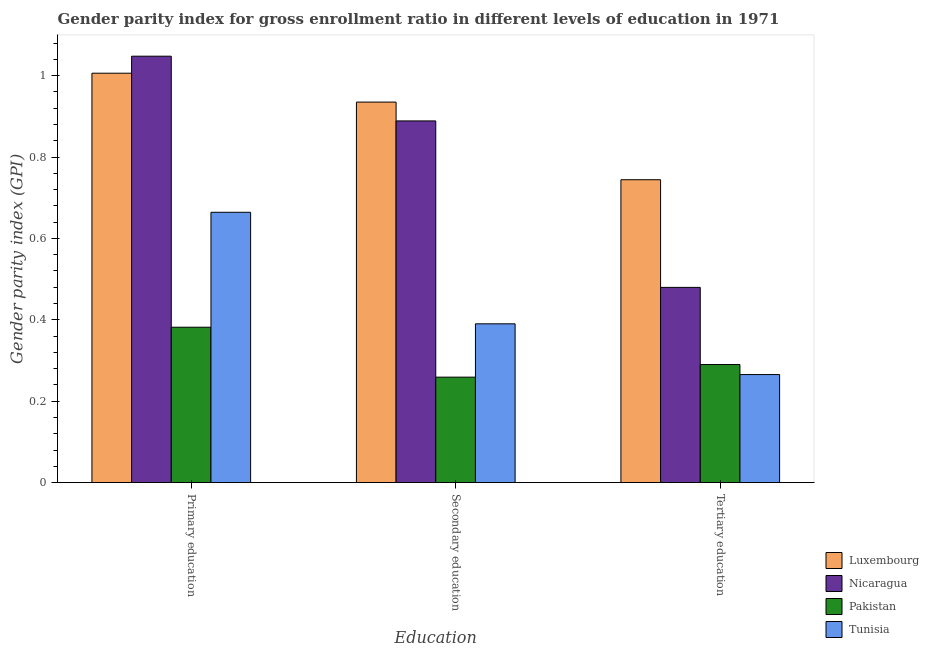How many groups of bars are there?
Provide a short and direct response. 3. How many bars are there on the 3rd tick from the right?
Ensure brevity in your answer.  4. What is the gender parity index in primary education in Nicaragua?
Provide a succinct answer. 1.05. Across all countries, what is the maximum gender parity index in tertiary education?
Your response must be concise. 0.74. Across all countries, what is the minimum gender parity index in tertiary education?
Your response must be concise. 0.27. In which country was the gender parity index in primary education maximum?
Offer a terse response. Nicaragua. In which country was the gender parity index in primary education minimum?
Offer a very short reply. Pakistan. What is the total gender parity index in secondary education in the graph?
Your answer should be very brief. 2.47. What is the difference between the gender parity index in tertiary education in Luxembourg and that in Pakistan?
Make the answer very short. 0.45. What is the difference between the gender parity index in primary education in Nicaragua and the gender parity index in secondary education in Luxembourg?
Keep it short and to the point. 0.11. What is the average gender parity index in tertiary education per country?
Make the answer very short. 0.44. What is the difference between the gender parity index in tertiary education and gender parity index in secondary education in Luxembourg?
Your answer should be very brief. -0.19. In how many countries, is the gender parity index in tertiary education greater than 0.4 ?
Provide a short and direct response. 2. What is the ratio of the gender parity index in secondary education in Pakistan to that in Luxembourg?
Keep it short and to the point. 0.28. Is the gender parity index in primary education in Luxembourg less than that in Nicaragua?
Offer a terse response. Yes. Is the difference between the gender parity index in secondary education in Nicaragua and Luxembourg greater than the difference between the gender parity index in primary education in Nicaragua and Luxembourg?
Ensure brevity in your answer.  No. What is the difference between the highest and the second highest gender parity index in tertiary education?
Give a very brief answer. 0.26. What is the difference between the highest and the lowest gender parity index in tertiary education?
Offer a very short reply. 0.48. In how many countries, is the gender parity index in tertiary education greater than the average gender parity index in tertiary education taken over all countries?
Your answer should be compact. 2. Is the sum of the gender parity index in primary education in Tunisia and Luxembourg greater than the maximum gender parity index in tertiary education across all countries?
Offer a terse response. Yes. What does the 2nd bar from the left in Primary education represents?
Offer a very short reply. Nicaragua. What does the 1st bar from the right in Secondary education represents?
Give a very brief answer. Tunisia. Is it the case that in every country, the sum of the gender parity index in primary education and gender parity index in secondary education is greater than the gender parity index in tertiary education?
Your answer should be very brief. Yes. Does the graph contain any zero values?
Give a very brief answer. No. Where does the legend appear in the graph?
Give a very brief answer. Bottom right. How many legend labels are there?
Offer a terse response. 4. What is the title of the graph?
Your response must be concise. Gender parity index for gross enrollment ratio in different levels of education in 1971. What is the label or title of the X-axis?
Keep it short and to the point. Education. What is the label or title of the Y-axis?
Provide a short and direct response. Gender parity index (GPI). What is the Gender parity index (GPI) of Luxembourg in Primary education?
Give a very brief answer. 1.01. What is the Gender parity index (GPI) of Nicaragua in Primary education?
Your answer should be very brief. 1.05. What is the Gender parity index (GPI) of Pakistan in Primary education?
Give a very brief answer. 0.38. What is the Gender parity index (GPI) of Tunisia in Primary education?
Ensure brevity in your answer.  0.66. What is the Gender parity index (GPI) in Luxembourg in Secondary education?
Offer a terse response. 0.93. What is the Gender parity index (GPI) of Nicaragua in Secondary education?
Ensure brevity in your answer.  0.89. What is the Gender parity index (GPI) of Pakistan in Secondary education?
Provide a succinct answer. 0.26. What is the Gender parity index (GPI) in Tunisia in Secondary education?
Provide a short and direct response. 0.39. What is the Gender parity index (GPI) in Luxembourg in Tertiary education?
Keep it short and to the point. 0.74. What is the Gender parity index (GPI) in Nicaragua in Tertiary education?
Keep it short and to the point. 0.48. What is the Gender parity index (GPI) in Pakistan in Tertiary education?
Provide a succinct answer. 0.29. What is the Gender parity index (GPI) of Tunisia in Tertiary education?
Provide a succinct answer. 0.27. Across all Education, what is the maximum Gender parity index (GPI) of Luxembourg?
Offer a terse response. 1.01. Across all Education, what is the maximum Gender parity index (GPI) of Nicaragua?
Your response must be concise. 1.05. Across all Education, what is the maximum Gender parity index (GPI) of Pakistan?
Make the answer very short. 0.38. Across all Education, what is the maximum Gender parity index (GPI) of Tunisia?
Your answer should be compact. 0.66. Across all Education, what is the minimum Gender parity index (GPI) of Luxembourg?
Keep it short and to the point. 0.74. Across all Education, what is the minimum Gender parity index (GPI) in Nicaragua?
Ensure brevity in your answer.  0.48. Across all Education, what is the minimum Gender parity index (GPI) of Pakistan?
Provide a succinct answer. 0.26. Across all Education, what is the minimum Gender parity index (GPI) in Tunisia?
Make the answer very short. 0.27. What is the total Gender parity index (GPI) of Luxembourg in the graph?
Keep it short and to the point. 2.69. What is the total Gender parity index (GPI) in Nicaragua in the graph?
Offer a very short reply. 2.42. What is the total Gender parity index (GPI) of Pakistan in the graph?
Keep it short and to the point. 0.93. What is the total Gender parity index (GPI) in Tunisia in the graph?
Offer a very short reply. 1.32. What is the difference between the Gender parity index (GPI) of Luxembourg in Primary education and that in Secondary education?
Your response must be concise. 0.07. What is the difference between the Gender parity index (GPI) of Nicaragua in Primary education and that in Secondary education?
Keep it short and to the point. 0.16. What is the difference between the Gender parity index (GPI) in Pakistan in Primary education and that in Secondary education?
Offer a very short reply. 0.12. What is the difference between the Gender parity index (GPI) in Tunisia in Primary education and that in Secondary education?
Ensure brevity in your answer.  0.27. What is the difference between the Gender parity index (GPI) of Luxembourg in Primary education and that in Tertiary education?
Your answer should be very brief. 0.26. What is the difference between the Gender parity index (GPI) in Nicaragua in Primary education and that in Tertiary education?
Offer a terse response. 0.57. What is the difference between the Gender parity index (GPI) of Pakistan in Primary education and that in Tertiary education?
Your answer should be compact. 0.09. What is the difference between the Gender parity index (GPI) of Tunisia in Primary education and that in Tertiary education?
Give a very brief answer. 0.4. What is the difference between the Gender parity index (GPI) of Luxembourg in Secondary education and that in Tertiary education?
Give a very brief answer. 0.19. What is the difference between the Gender parity index (GPI) of Nicaragua in Secondary education and that in Tertiary education?
Provide a succinct answer. 0.41. What is the difference between the Gender parity index (GPI) in Pakistan in Secondary education and that in Tertiary education?
Ensure brevity in your answer.  -0.03. What is the difference between the Gender parity index (GPI) in Tunisia in Secondary education and that in Tertiary education?
Keep it short and to the point. 0.12. What is the difference between the Gender parity index (GPI) in Luxembourg in Primary education and the Gender parity index (GPI) in Nicaragua in Secondary education?
Your answer should be compact. 0.12. What is the difference between the Gender parity index (GPI) in Luxembourg in Primary education and the Gender parity index (GPI) in Pakistan in Secondary education?
Ensure brevity in your answer.  0.75. What is the difference between the Gender parity index (GPI) in Luxembourg in Primary education and the Gender parity index (GPI) in Tunisia in Secondary education?
Your answer should be very brief. 0.62. What is the difference between the Gender parity index (GPI) in Nicaragua in Primary education and the Gender parity index (GPI) in Pakistan in Secondary education?
Offer a very short reply. 0.79. What is the difference between the Gender parity index (GPI) in Nicaragua in Primary education and the Gender parity index (GPI) in Tunisia in Secondary education?
Your answer should be very brief. 0.66. What is the difference between the Gender parity index (GPI) of Pakistan in Primary education and the Gender parity index (GPI) of Tunisia in Secondary education?
Provide a short and direct response. -0.01. What is the difference between the Gender parity index (GPI) in Luxembourg in Primary education and the Gender parity index (GPI) in Nicaragua in Tertiary education?
Give a very brief answer. 0.53. What is the difference between the Gender parity index (GPI) in Luxembourg in Primary education and the Gender parity index (GPI) in Pakistan in Tertiary education?
Offer a terse response. 0.72. What is the difference between the Gender parity index (GPI) in Luxembourg in Primary education and the Gender parity index (GPI) in Tunisia in Tertiary education?
Give a very brief answer. 0.74. What is the difference between the Gender parity index (GPI) of Nicaragua in Primary education and the Gender parity index (GPI) of Pakistan in Tertiary education?
Offer a terse response. 0.76. What is the difference between the Gender parity index (GPI) of Nicaragua in Primary education and the Gender parity index (GPI) of Tunisia in Tertiary education?
Provide a succinct answer. 0.78. What is the difference between the Gender parity index (GPI) of Pakistan in Primary education and the Gender parity index (GPI) of Tunisia in Tertiary education?
Your response must be concise. 0.12. What is the difference between the Gender parity index (GPI) of Luxembourg in Secondary education and the Gender parity index (GPI) of Nicaragua in Tertiary education?
Offer a terse response. 0.46. What is the difference between the Gender parity index (GPI) in Luxembourg in Secondary education and the Gender parity index (GPI) in Pakistan in Tertiary education?
Keep it short and to the point. 0.64. What is the difference between the Gender parity index (GPI) of Luxembourg in Secondary education and the Gender parity index (GPI) of Tunisia in Tertiary education?
Keep it short and to the point. 0.67. What is the difference between the Gender parity index (GPI) of Nicaragua in Secondary education and the Gender parity index (GPI) of Pakistan in Tertiary education?
Keep it short and to the point. 0.6. What is the difference between the Gender parity index (GPI) of Nicaragua in Secondary education and the Gender parity index (GPI) of Tunisia in Tertiary education?
Ensure brevity in your answer.  0.62. What is the difference between the Gender parity index (GPI) of Pakistan in Secondary education and the Gender parity index (GPI) of Tunisia in Tertiary education?
Keep it short and to the point. -0.01. What is the average Gender parity index (GPI) of Luxembourg per Education?
Make the answer very short. 0.9. What is the average Gender parity index (GPI) of Nicaragua per Education?
Keep it short and to the point. 0.81. What is the average Gender parity index (GPI) of Pakistan per Education?
Keep it short and to the point. 0.31. What is the average Gender parity index (GPI) in Tunisia per Education?
Your answer should be compact. 0.44. What is the difference between the Gender parity index (GPI) in Luxembourg and Gender parity index (GPI) in Nicaragua in Primary education?
Your answer should be compact. -0.04. What is the difference between the Gender parity index (GPI) of Luxembourg and Gender parity index (GPI) of Pakistan in Primary education?
Ensure brevity in your answer.  0.62. What is the difference between the Gender parity index (GPI) in Luxembourg and Gender parity index (GPI) in Tunisia in Primary education?
Your answer should be compact. 0.34. What is the difference between the Gender parity index (GPI) in Nicaragua and Gender parity index (GPI) in Pakistan in Primary education?
Keep it short and to the point. 0.67. What is the difference between the Gender parity index (GPI) of Nicaragua and Gender parity index (GPI) of Tunisia in Primary education?
Give a very brief answer. 0.38. What is the difference between the Gender parity index (GPI) in Pakistan and Gender parity index (GPI) in Tunisia in Primary education?
Your answer should be very brief. -0.28. What is the difference between the Gender parity index (GPI) of Luxembourg and Gender parity index (GPI) of Nicaragua in Secondary education?
Give a very brief answer. 0.05. What is the difference between the Gender parity index (GPI) in Luxembourg and Gender parity index (GPI) in Pakistan in Secondary education?
Your answer should be compact. 0.68. What is the difference between the Gender parity index (GPI) in Luxembourg and Gender parity index (GPI) in Tunisia in Secondary education?
Offer a very short reply. 0.54. What is the difference between the Gender parity index (GPI) in Nicaragua and Gender parity index (GPI) in Pakistan in Secondary education?
Provide a short and direct response. 0.63. What is the difference between the Gender parity index (GPI) of Nicaragua and Gender parity index (GPI) of Tunisia in Secondary education?
Your answer should be very brief. 0.5. What is the difference between the Gender parity index (GPI) of Pakistan and Gender parity index (GPI) of Tunisia in Secondary education?
Your answer should be compact. -0.13. What is the difference between the Gender parity index (GPI) in Luxembourg and Gender parity index (GPI) in Nicaragua in Tertiary education?
Offer a terse response. 0.26. What is the difference between the Gender parity index (GPI) in Luxembourg and Gender parity index (GPI) in Pakistan in Tertiary education?
Give a very brief answer. 0.45. What is the difference between the Gender parity index (GPI) of Luxembourg and Gender parity index (GPI) of Tunisia in Tertiary education?
Give a very brief answer. 0.48. What is the difference between the Gender parity index (GPI) in Nicaragua and Gender parity index (GPI) in Pakistan in Tertiary education?
Provide a succinct answer. 0.19. What is the difference between the Gender parity index (GPI) of Nicaragua and Gender parity index (GPI) of Tunisia in Tertiary education?
Your answer should be very brief. 0.21. What is the difference between the Gender parity index (GPI) of Pakistan and Gender parity index (GPI) of Tunisia in Tertiary education?
Offer a terse response. 0.02. What is the ratio of the Gender parity index (GPI) of Luxembourg in Primary education to that in Secondary education?
Your answer should be very brief. 1.08. What is the ratio of the Gender parity index (GPI) in Nicaragua in Primary education to that in Secondary education?
Offer a very short reply. 1.18. What is the ratio of the Gender parity index (GPI) in Pakistan in Primary education to that in Secondary education?
Offer a very short reply. 1.47. What is the ratio of the Gender parity index (GPI) of Tunisia in Primary education to that in Secondary education?
Keep it short and to the point. 1.7. What is the ratio of the Gender parity index (GPI) in Luxembourg in Primary education to that in Tertiary education?
Offer a very short reply. 1.35. What is the ratio of the Gender parity index (GPI) in Nicaragua in Primary education to that in Tertiary education?
Offer a very short reply. 2.18. What is the ratio of the Gender parity index (GPI) of Pakistan in Primary education to that in Tertiary education?
Provide a succinct answer. 1.32. What is the ratio of the Gender parity index (GPI) of Tunisia in Primary education to that in Tertiary education?
Your answer should be very brief. 2.5. What is the ratio of the Gender parity index (GPI) in Luxembourg in Secondary education to that in Tertiary education?
Give a very brief answer. 1.26. What is the ratio of the Gender parity index (GPI) of Nicaragua in Secondary education to that in Tertiary education?
Ensure brevity in your answer.  1.85. What is the ratio of the Gender parity index (GPI) in Pakistan in Secondary education to that in Tertiary education?
Ensure brevity in your answer.  0.89. What is the ratio of the Gender parity index (GPI) in Tunisia in Secondary education to that in Tertiary education?
Offer a terse response. 1.47. What is the difference between the highest and the second highest Gender parity index (GPI) of Luxembourg?
Provide a short and direct response. 0.07. What is the difference between the highest and the second highest Gender parity index (GPI) in Nicaragua?
Offer a terse response. 0.16. What is the difference between the highest and the second highest Gender parity index (GPI) of Pakistan?
Give a very brief answer. 0.09. What is the difference between the highest and the second highest Gender parity index (GPI) in Tunisia?
Provide a succinct answer. 0.27. What is the difference between the highest and the lowest Gender parity index (GPI) of Luxembourg?
Make the answer very short. 0.26. What is the difference between the highest and the lowest Gender parity index (GPI) in Nicaragua?
Provide a short and direct response. 0.57. What is the difference between the highest and the lowest Gender parity index (GPI) in Pakistan?
Your response must be concise. 0.12. What is the difference between the highest and the lowest Gender parity index (GPI) of Tunisia?
Make the answer very short. 0.4. 